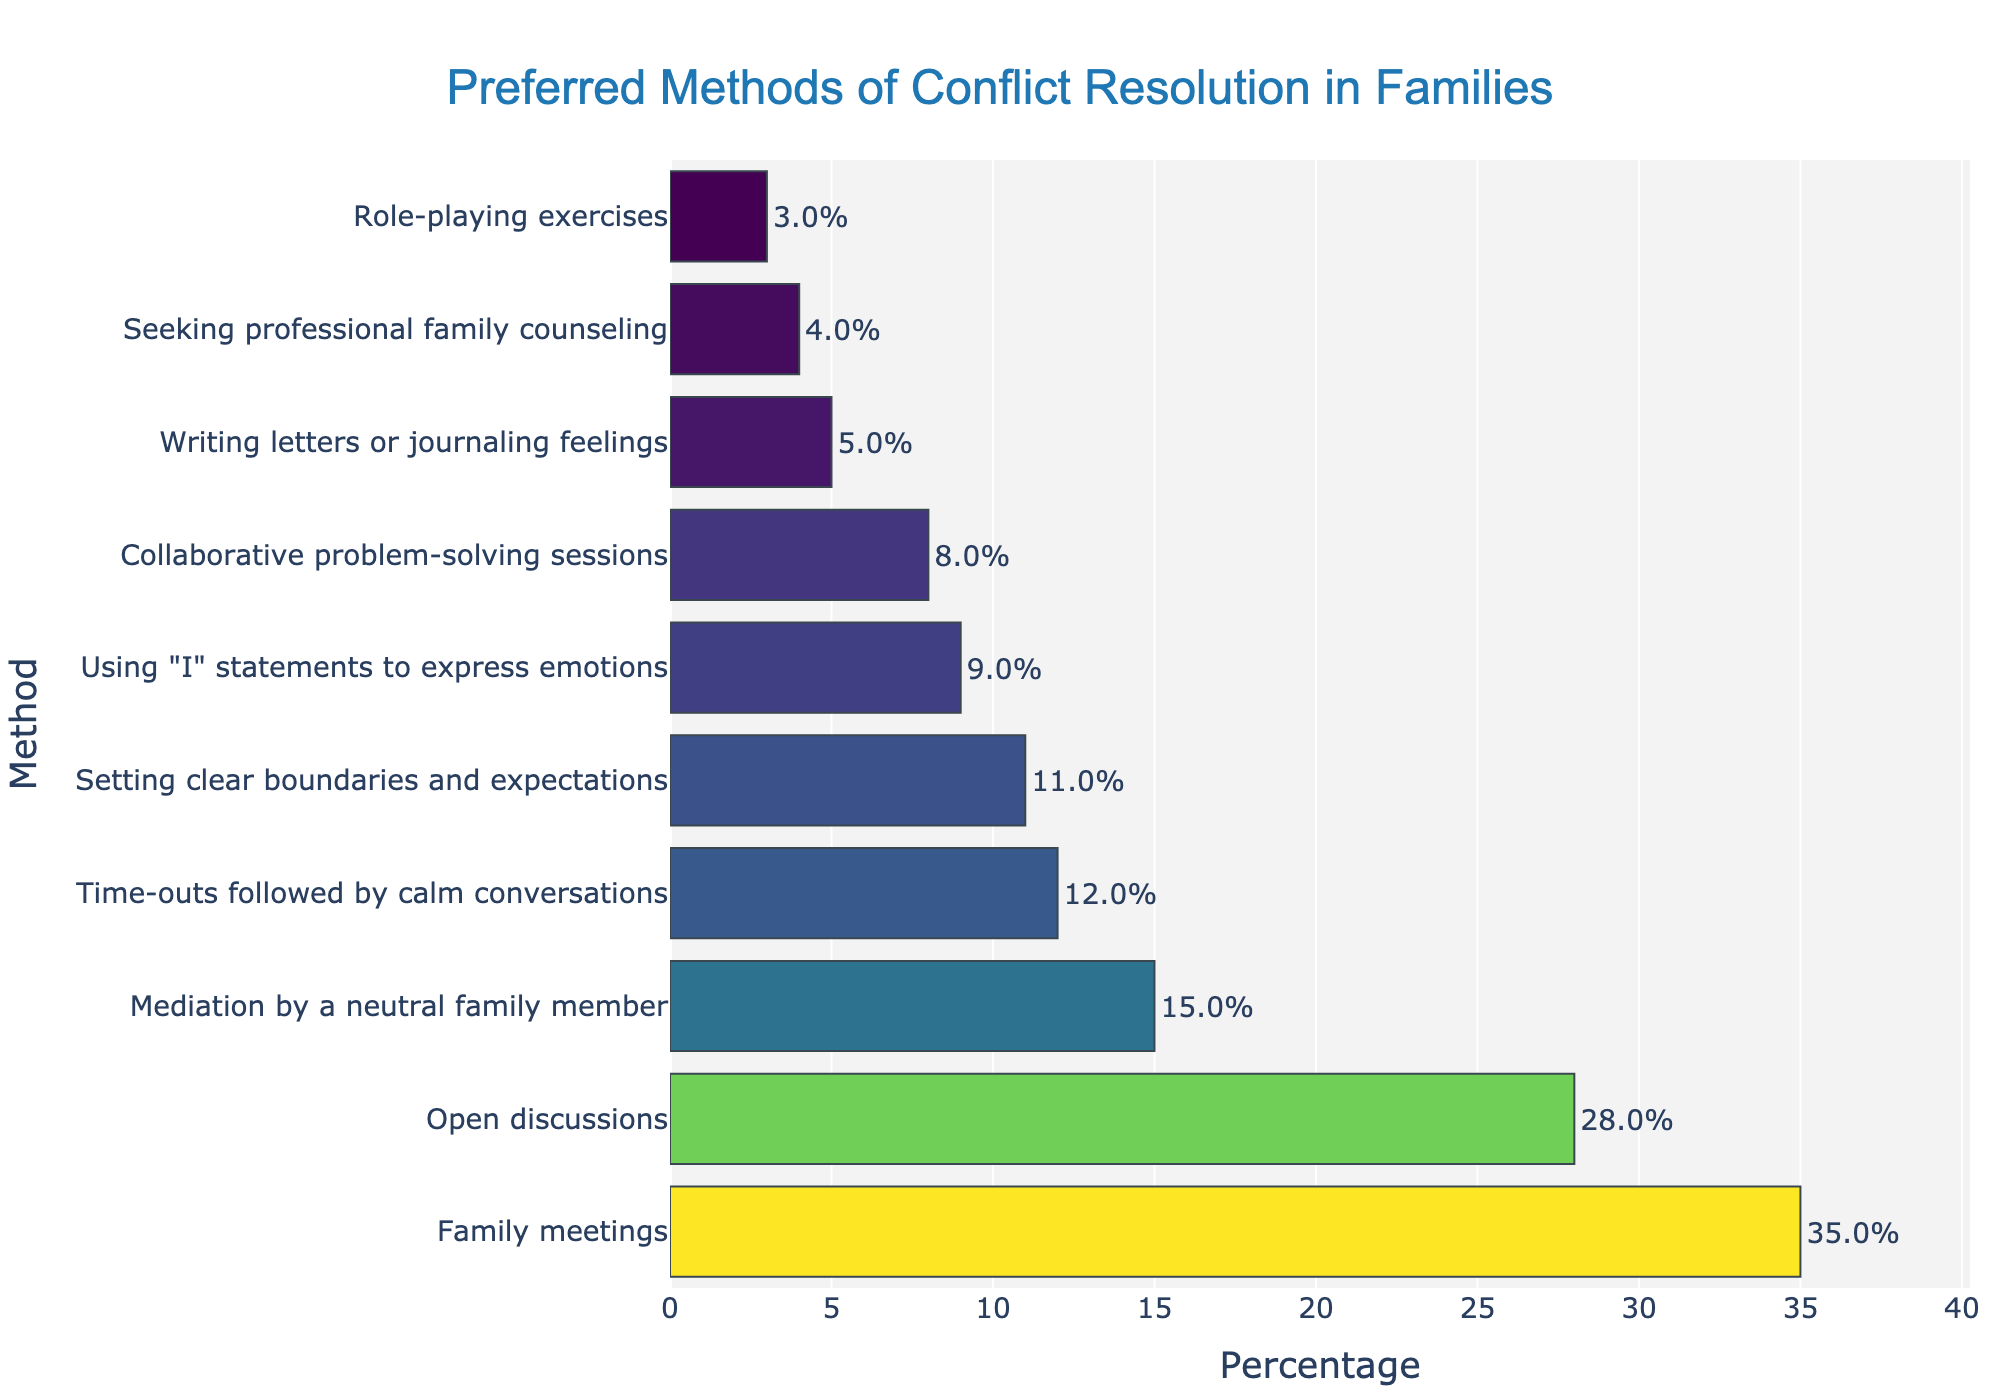Which method of conflict resolution is preferred the most? The bar chart shows the methods ranked by percentage. The largest bar is for "Family meetings" at 35%.
Answer: Family meetings How much more popular is "Open discussions" compared to "Seeking professional family counseling"? "Open discussions" has a bar with 28%, and "Seeking professional family counseling" has a bar with 4%. So the difference is 28% - 4% = 24%.
Answer: 24% What's the combined percentage of methods involving direct conversation (Family meetings, Open discussions, Using "I" statements, Setting clear boundaries and expectations)? Sum the percentages for these methods: 35% + 28% + 9% + 11% = 83%.
Answer: 83% Which method has the lowest percentage, and what is that percentage? The shortest bar corresponds to "Role-playing exercises" at 3%.
Answer: Role-playing exercises, 3% Compare the popularity of "Writing letters or journaling feelings" and "Time-outs followed by calm conversations." Which is more favored and by how much? "Writing letters or journaling feelings" has a percentage of 5%, while "Time-outs followed by calm conversations" has 12%. The difference is 12% - 5% = 7%.
Answer: Time-outs followed by calm conversations, 7% Among the methods listed, how many have a percentage greater than 10%? Count the bars with percentages greater than 10%: Family meetings (35%), Open discussions (28%), Mediation by a neutral family member (15%), Setting clear boundaries and expectations (11%), and Time-outs followed by calm conversations (12%). There are 5 methods.
Answer: 5 What is the percentage of methods related to "problem-solving" (Collaborative problem-solving sessions and Mediation by a neutral family member)? Add the percentages for these two methods: 8% + 15% = 23%.
Answer: 23% What is the more common method between "Family meetings" and "Collaborative problem-solving sessions"? "Family meetings" is at 35%, while "Collaborative problem-solving sessions" is at 8%, making "Family meetings" the more common method.
Answer: Family meetings What percentage of families prefer methods that involve structured sessions (Family meetings, Mediation by a neutral family member, Collaborative problem-solving sessions, Seeking professional family counseling)? Sum the percentages of these methods: 35% + 15% + 8% + 4% = 62%.
Answer: 62% Which method with an emotional expression focus is more prevalent, "Writing letters or journaling feelings" or "Using 'I' statements to express emotions"? "Writing letters or journaling feelings" is at 5%, while "Using 'I' statements to express emotions" is at 9%. The latter is more prevalent.
Answer: Using 'I' statements to express emotions 